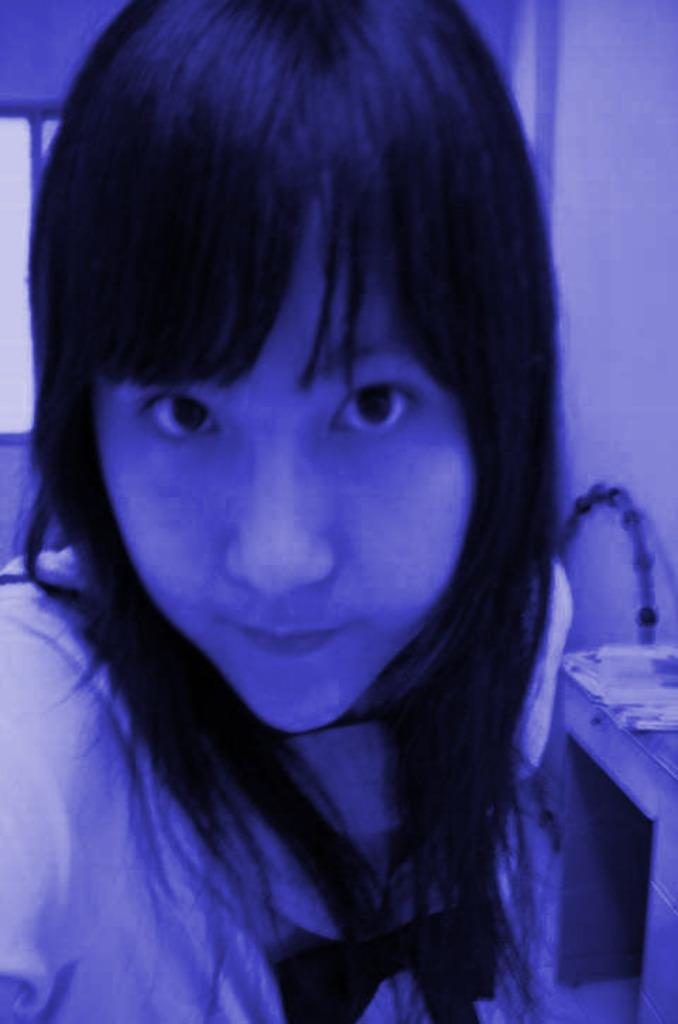Who is in the image? There is a woman in the image. What is located on the right side of the image? There is a table on the right side of the image. What is on the table? Papers are present on the table. What can be seen on the right side of the image besides the table? There is a ring on the right side of the image. What is visible in the image that provides a view of the outside? There is a window visible in the image. What type of railway is visible in the image? There is no railway present in the image. What date is shown on the calendar in the image? There is no calendar present in the image. 